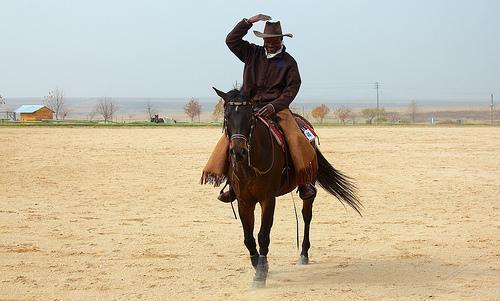How many horses are there?
Give a very brief answer. 1. 